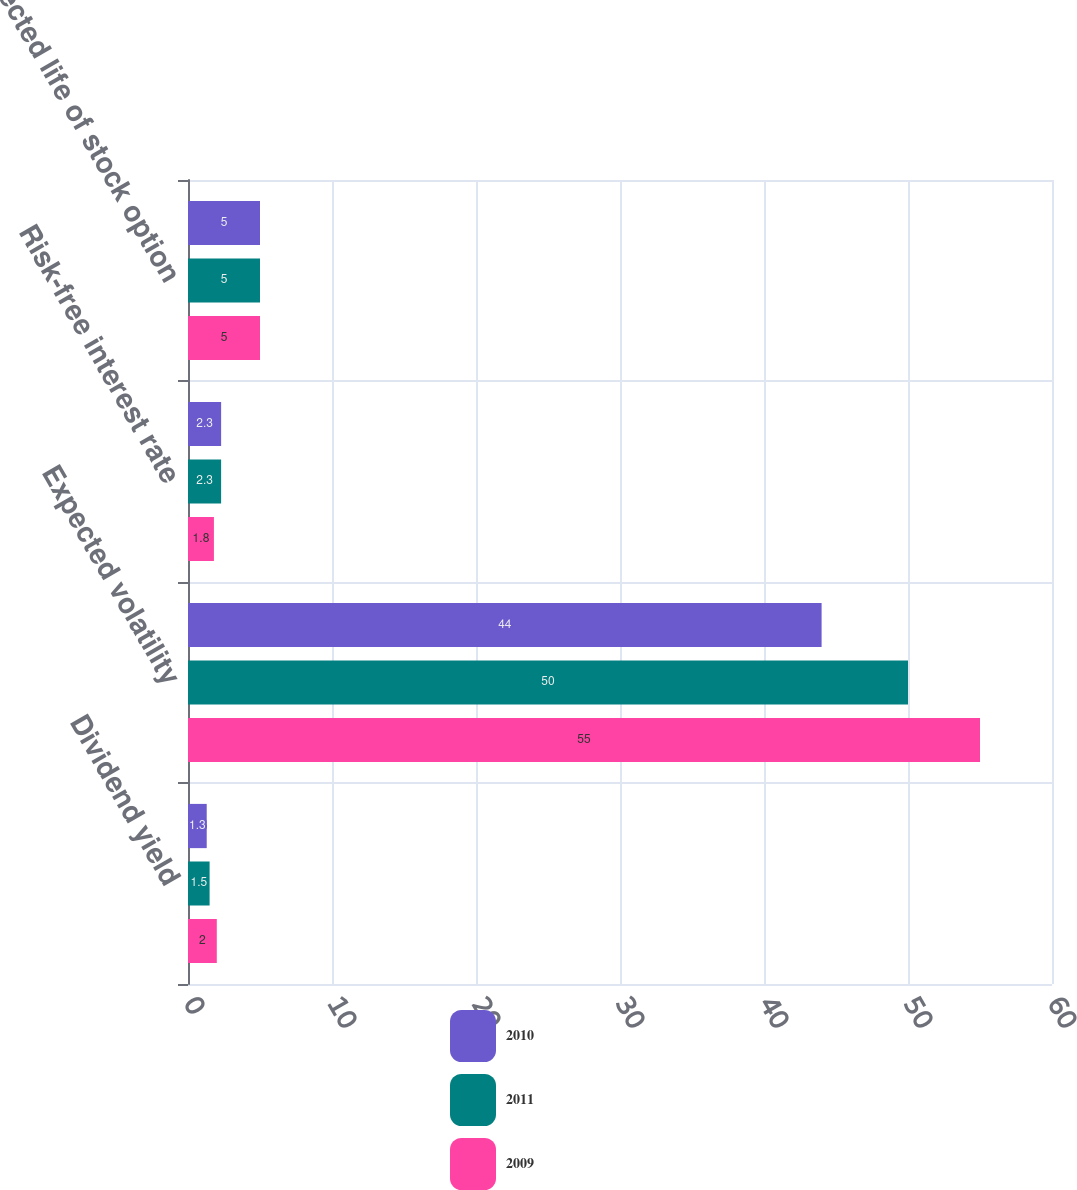Convert chart to OTSL. <chart><loc_0><loc_0><loc_500><loc_500><stacked_bar_chart><ecel><fcel>Dividend yield<fcel>Expected volatility<fcel>Risk-free interest rate<fcel>Expected life of stock option<nl><fcel>2010<fcel>1.3<fcel>44<fcel>2.3<fcel>5<nl><fcel>2011<fcel>1.5<fcel>50<fcel>2.3<fcel>5<nl><fcel>2009<fcel>2<fcel>55<fcel>1.8<fcel>5<nl></chart> 